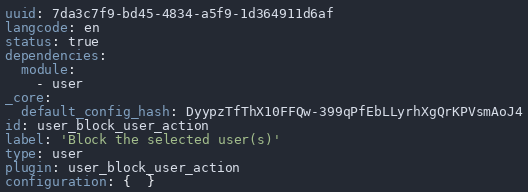Convert code to text. <code><loc_0><loc_0><loc_500><loc_500><_YAML_>uuid: 7da3c7f9-bd45-4834-a5f9-1d364911d6af
langcode: en
status: true
dependencies:
  module:
    - user
_core:
  default_config_hash: DyypzTfThX10FFQw-399qPfEbLLyrhXgQrKPVsmAoJ4
id: user_block_user_action
label: 'Block the selected user(s)'
type: user
plugin: user_block_user_action
configuration: {  }
</code> 